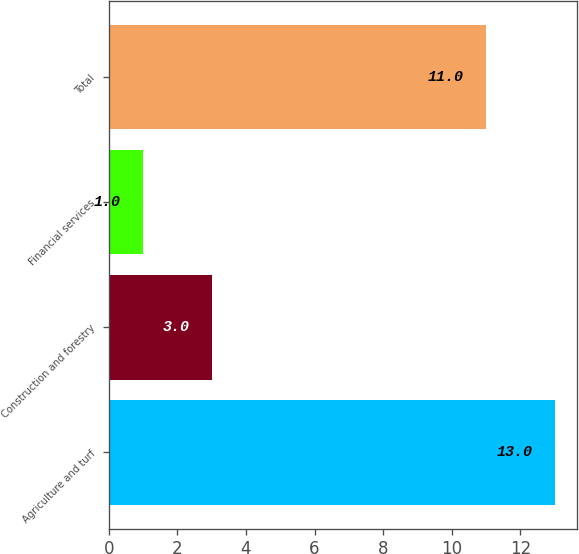Convert chart. <chart><loc_0><loc_0><loc_500><loc_500><bar_chart><fcel>Agriculture and turf<fcel>Construction and forestry<fcel>Financial services<fcel>Total<nl><fcel>13<fcel>3<fcel>1<fcel>11<nl></chart> 